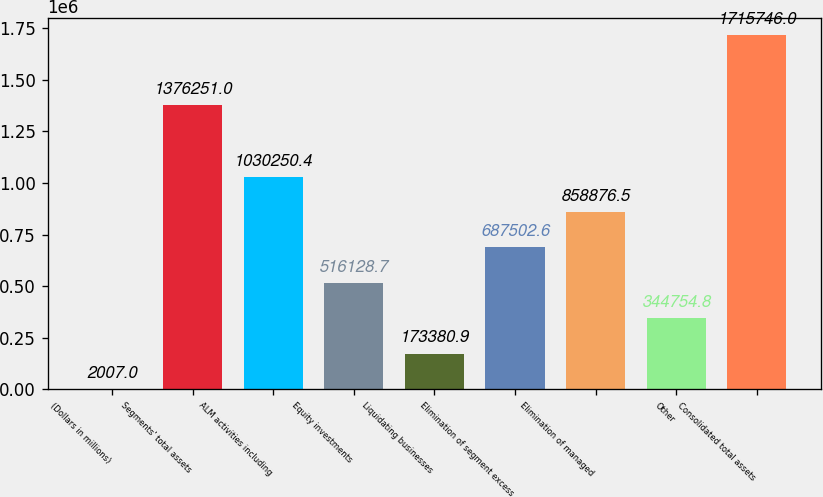Convert chart. <chart><loc_0><loc_0><loc_500><loc_500><bar_chart><fcel>(Dollars in millions)<fcel>Segments' total assets<fcel>ALM activities including<fcel>Equity investments<fcel>Liquidating businesses<fcel>Elimination of segment excess<fcel>Elimination of managed<fcel>Other<fcel>Consolidated total assets<nl><fcel>2007<fcel>1.37625e+06<fcel>1.03025e+06<fcel>516129<fcel>173381<fcel>687503<fcel>858876<fcel>344755<fcel>1.71575e+06<nl></chart> 